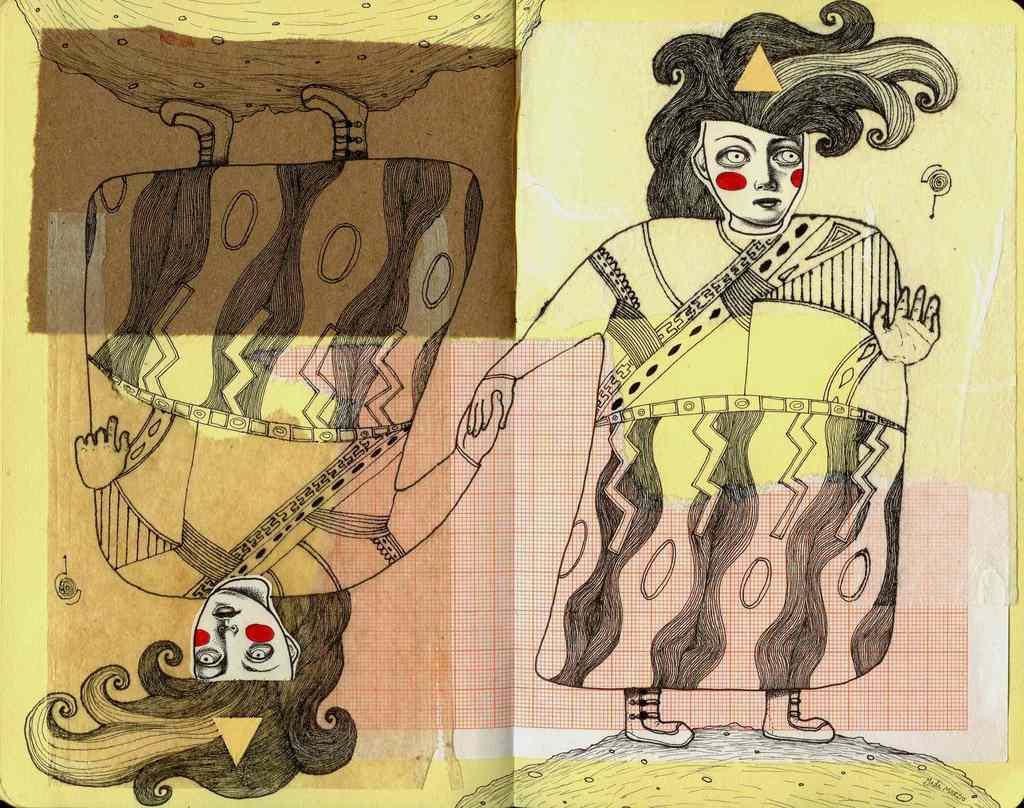In one or two sentences, can you explain what this image depicts? In the image there are some drawings and there is a piece of a graph paper. 